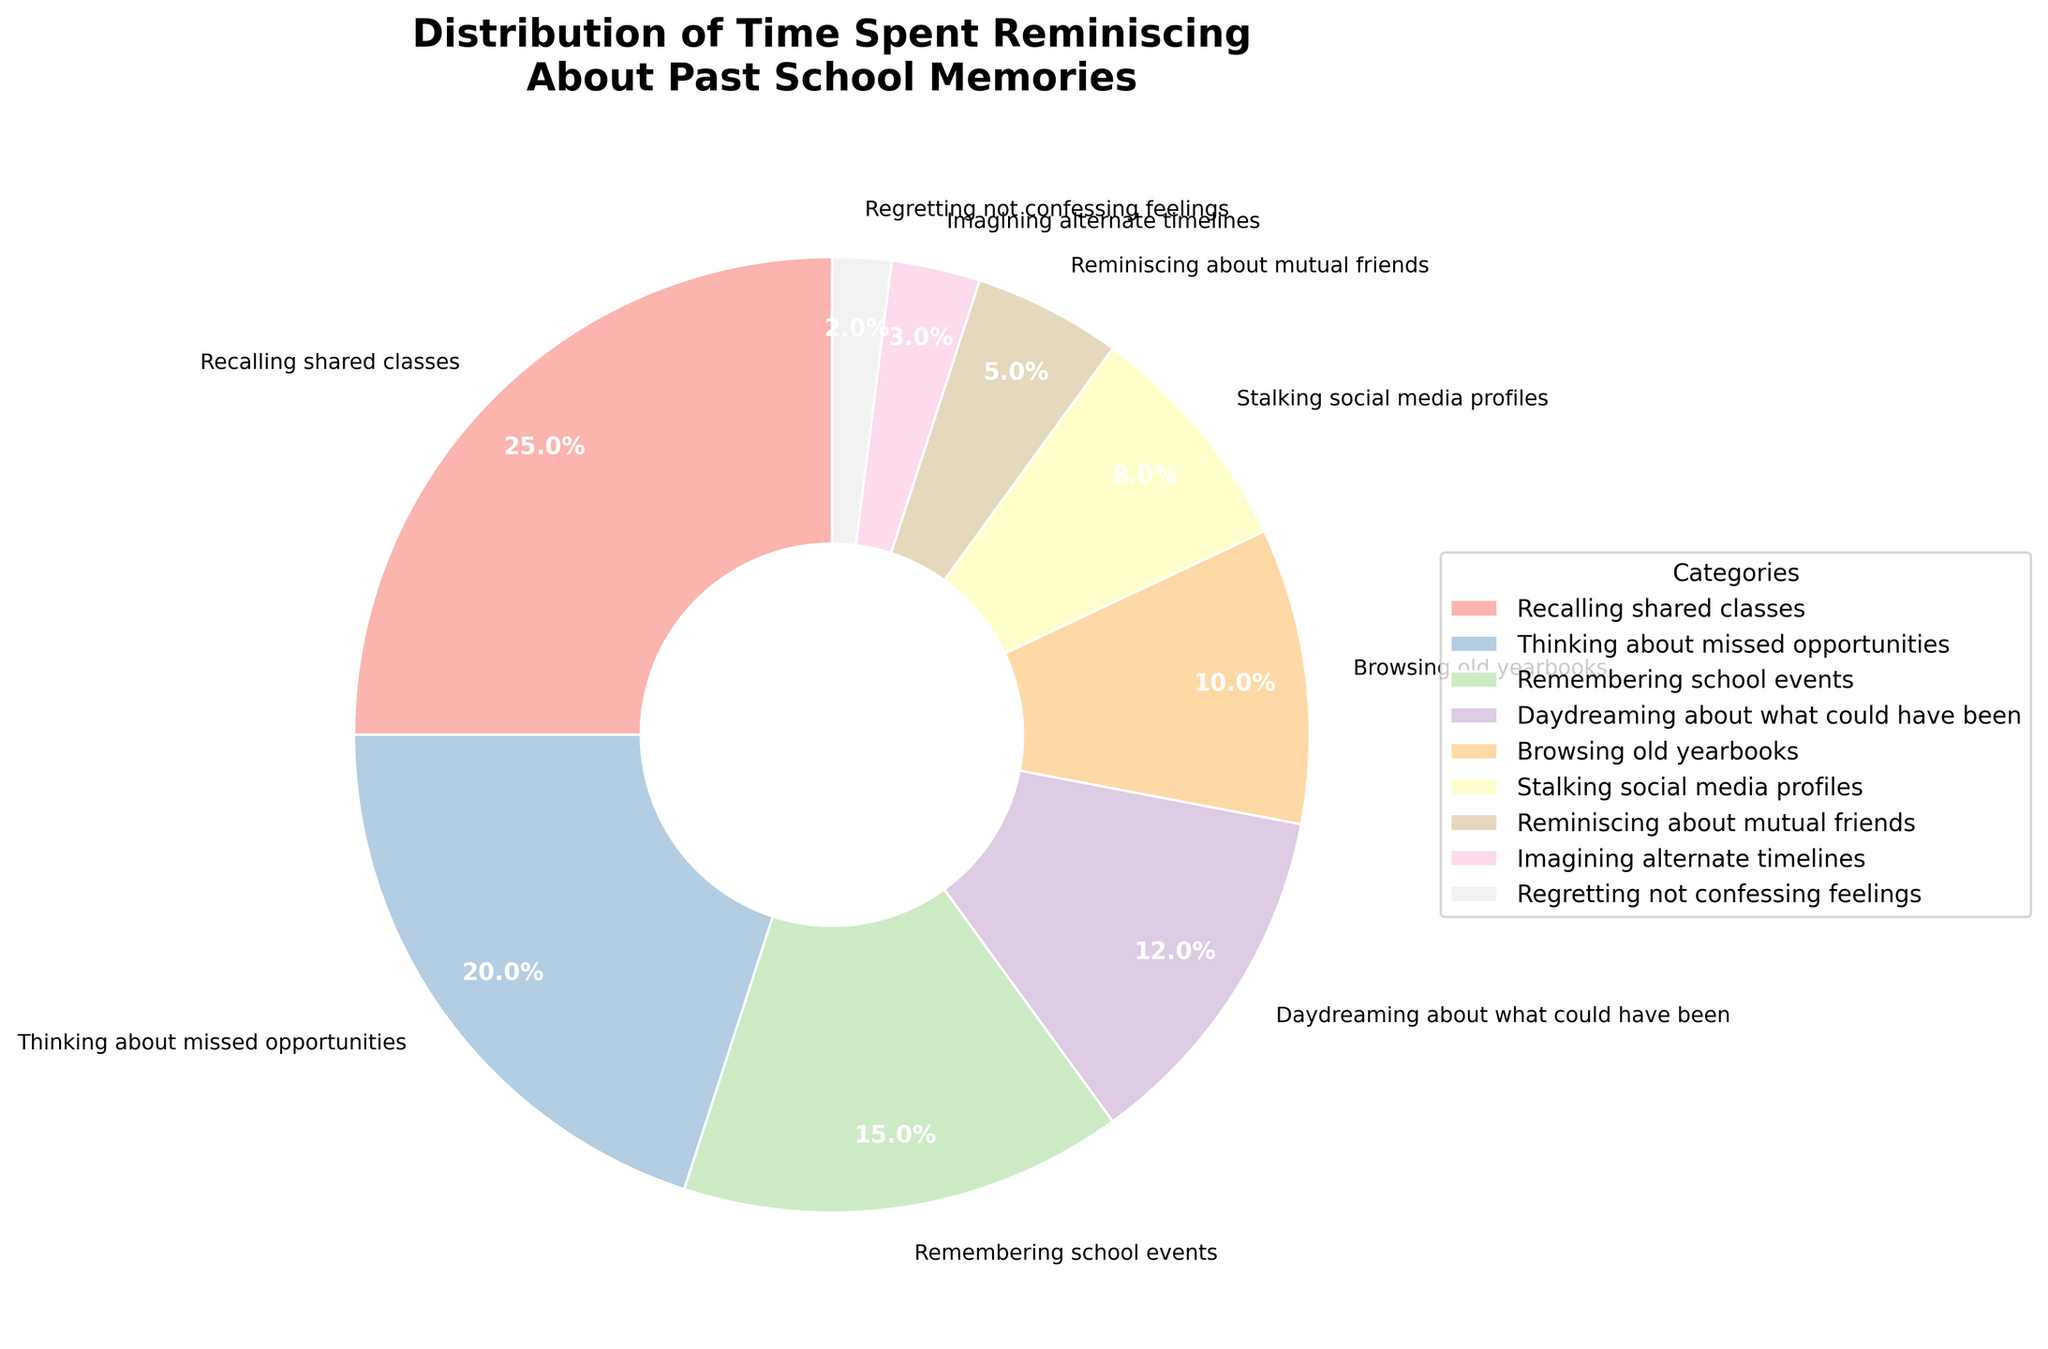What's the most time-consuming category? The slice corresponding to "Recalling shared classes" is the largest, occupying the most area in the pie chart. It has a percentage of 25%, making it the most time-consuming category.
Answer: Recalling shared classes Which category occupies the smallest segment of the pie chart? The smallest slice is labeled "Regretting not confessing feelings", representing just 2% of the chart.
Answer: Regretting not confessing feelings How much total time is spent on "Thinking about missed opportunities" and "Remembering school events"? The percentages for "Thinking about missed opportunities" and "Remembering school events" are 20% and 15%, respectively. Adding them together gives 20% + 15% = 35%.
Answer: 35% Which categories take up more than 10% of the pie chart? By looking at the chart, the slices for "Recalling shared classes" (25%), "Thinking about missed opportunities" (20%), Remembering school events (15%), and "Daydreaming about what could have been" (12%) are larger than 10%.
Answer: Recalling shared classes, Thinking about missed opportunities, Remembering school events, Daydreaming about what could have been What is the difference in time spent between the largest and smallest categories? The largest category "Recalling shared classes" takes up 25%, and the smallest category "Regretting not confessing feelings" takes up 2%. Subtracting these gives 25% - 2% = 23%.
Answer: 23% Compare the combined time spent on "Stalking social media profiles" and "Imagining alternate timelines" with the time spent on "Daydreaming about what could have been". Which is greater? "Stalking social media profiles" and "Imagining alternate timelines" add up to 8% + 3% = 11%. "Daydreaming about what could have been" alone is 12%. Therefore, "Daydreaming about what could have been" is greater.
Answer: Daydreaming about what could have been What is the average time spent on all categories? Adding all the percentages together: 25% + 20% + 15% + 12% + 10% + 8% + 5% + 3% + 2% = 100%. There are 9 categories. So the average is 100% / 9 ≈ 11.11%.
Answer: 11.11% Which category that occupies between 5% and 10% takes up the highest percentage? Among the categories within the 5% to 10% range, "Browsing old yearbooks" has 10%, "Stalking social media profiles" has 8%, and "Reminiscing about mutual friends" has 5%. The highest is 10%.
Answer: Browsing old yearbooks 